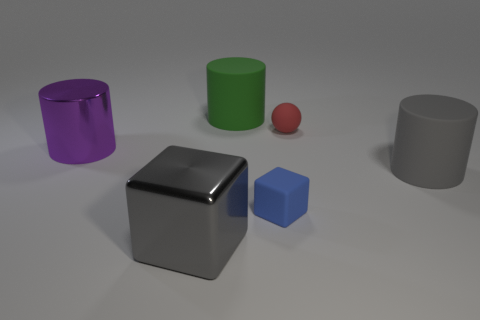Subtract all large gray rubber cylinders. How many cylinders are left? 2 Add 1 large purple metal objects. How many objects exist? 7 Subtract all blocks. How many objects are left? 4 Subtract all brown cylinders. Subtract all red cubes. How many cylinders are left? 3 Subtract 0 green balls. How many objects are left? 6 Subtract all small rubber things. Subtract all big purple objects. How many objects are left? 3 Add 3 rubber objects. How many rubber objects are left? 7 Add 4 red objects. How many red objects exist? 5 